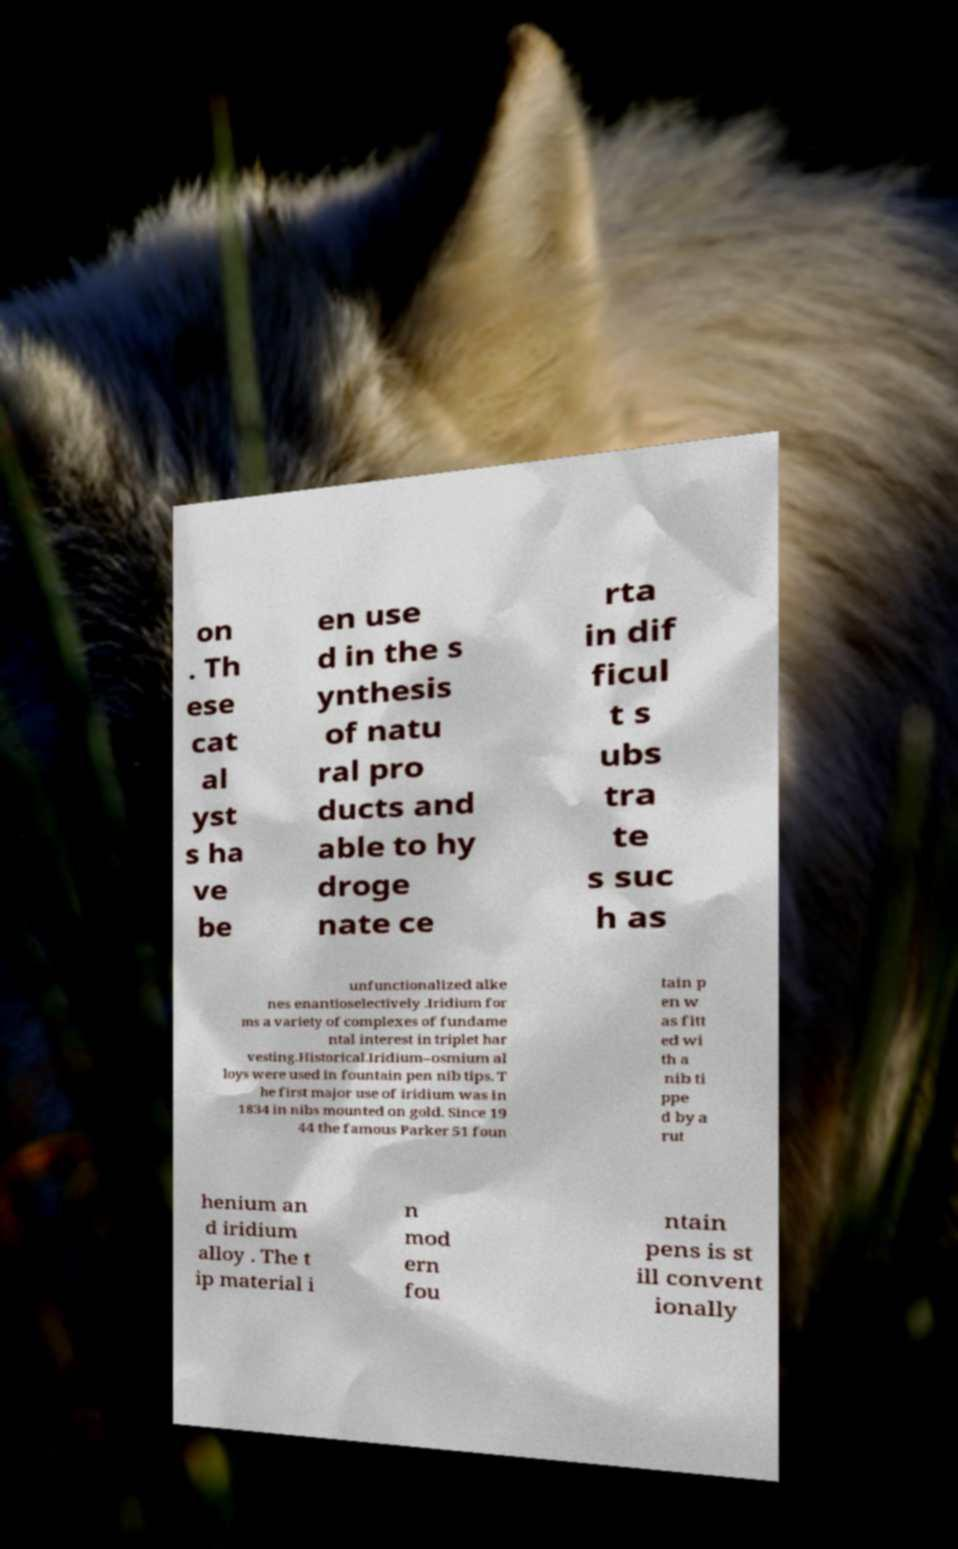Could you extract and type out the text from this image? on . Th ese cat al yst s ha ve be en use d in the s ynthesis of natu ral pro ducts and able to hy droge nate ce rta in dif ficul t s ubs tra te s suc h as unfunctionalized alke nes enantioselectively .Iridium for ms a variety of complexes of fundame ntal interest in triplet har vesting.Historical.Iridium–osmium al loys were used in fountain pen nib tips. T he first major use of iridium was in 1834 in nibs mounted on gold. Since 19 44 the famous Parker 51 foun tain p en w as fitt ed wi th a nib ti ppe d by a rut henium an d iridium alloy . The t ip material i n mod ern fou ntain pens is st ill convent ionally 